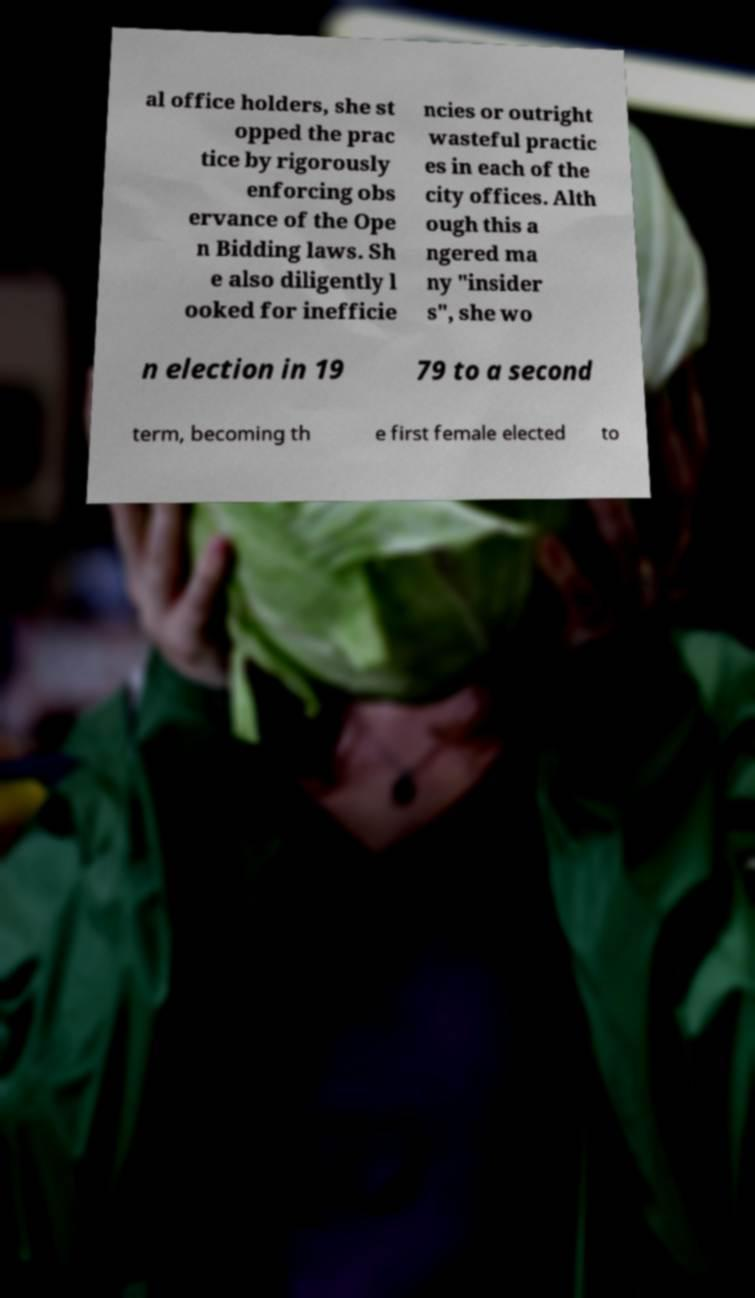Can you accurately transcribe the text from the provided image for me? al office holders, she st opped the prac tice by rigorously enforcing obs ervance of the Ope n Bidding laws. Sh e also diligently l ooked for inefficie ncies or outright wasteful practic es in each of the city offices. Alth ough this a ngered ma ny "insider s", she wo n election in 19 79 to a second term, becoming th e first female elected to 